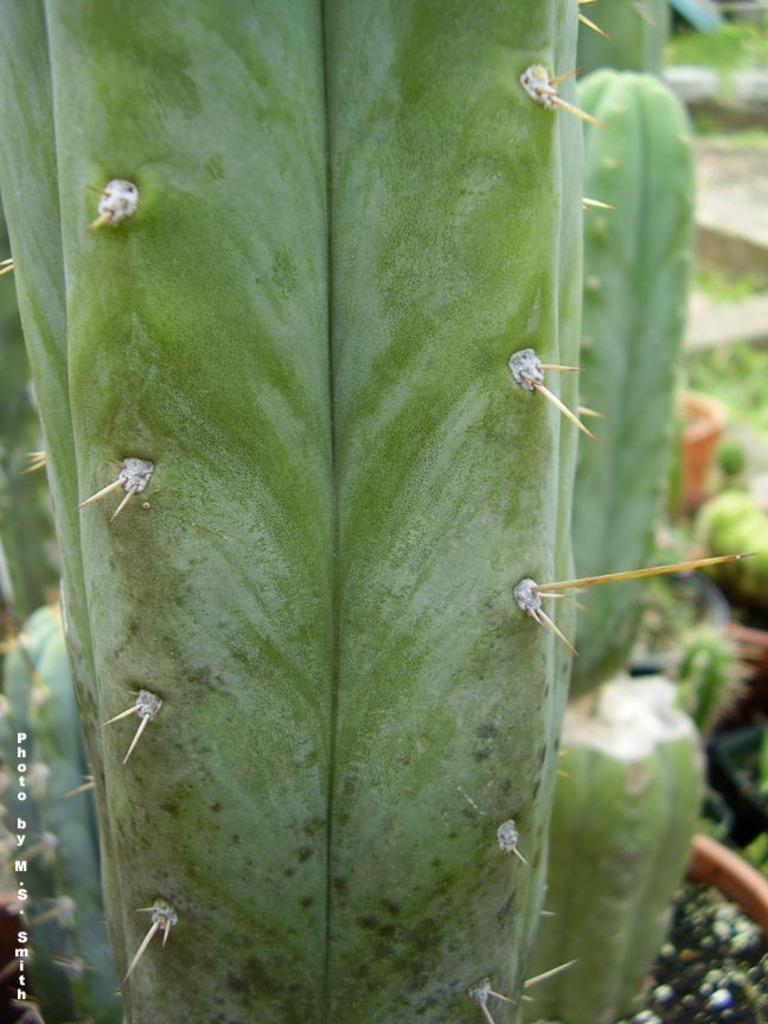What type of living organisms can be seen in the image? Plants can be seen in the image. What time of day is depicted in the image? The time of day cannot be determined from the image, as there is no information about lighting or shadows to suggest a specific time. 